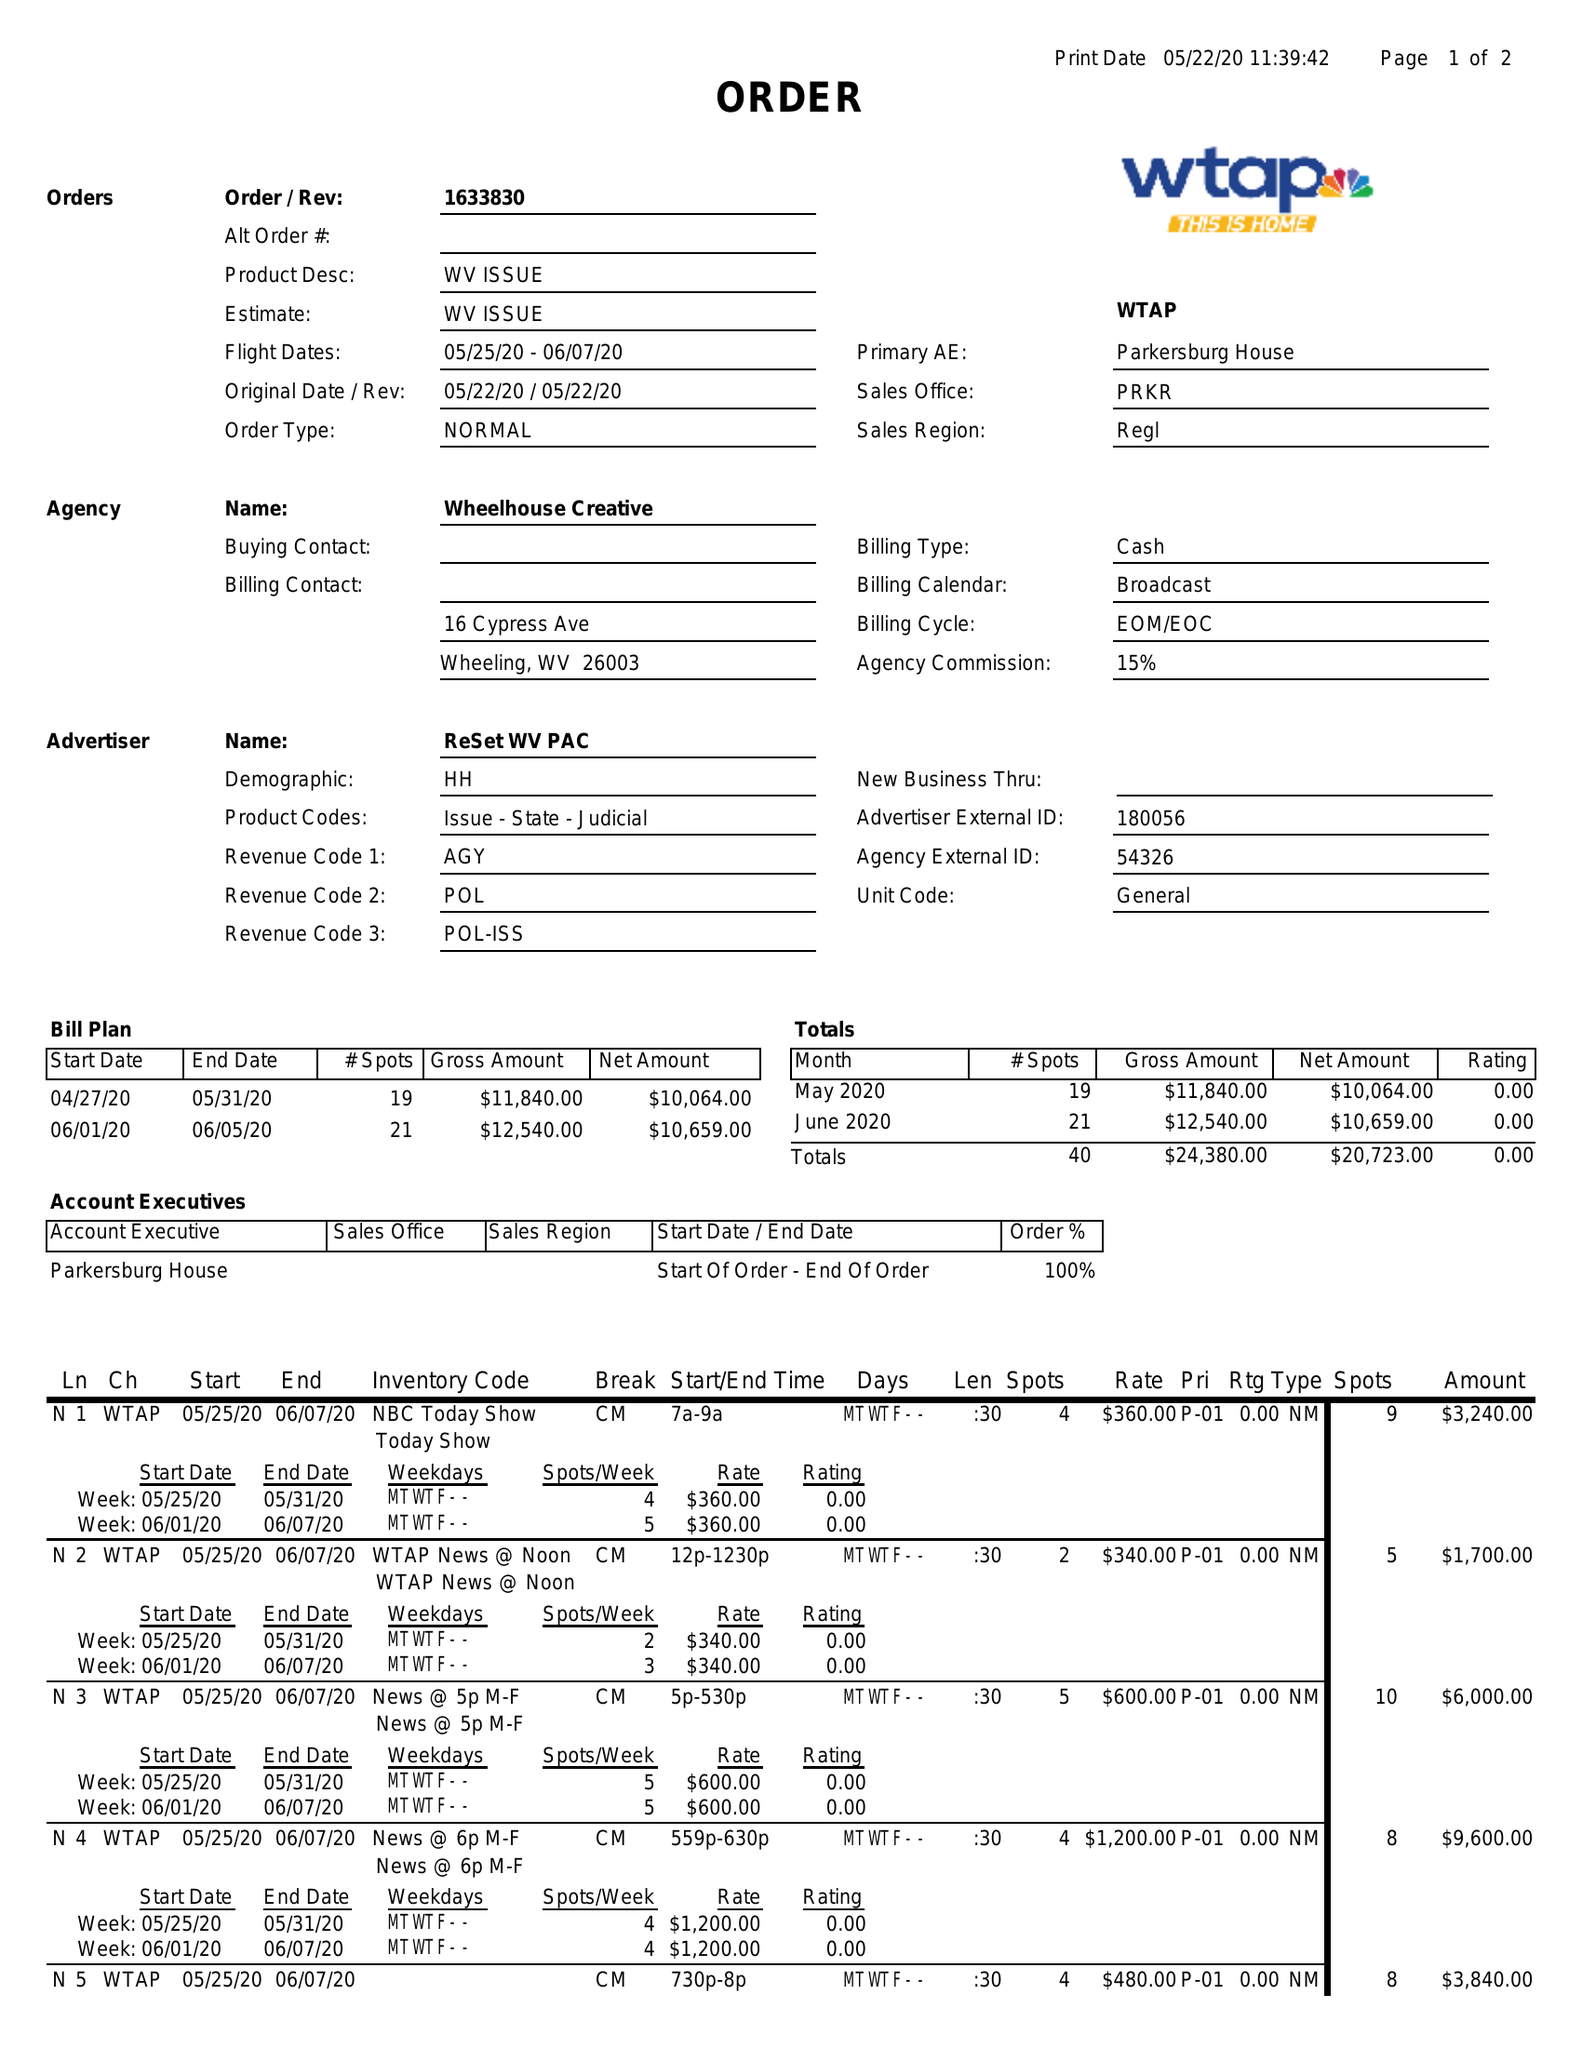What is the value for the flight_to?
Answer the question using a single word or phrase. 06/07/20 